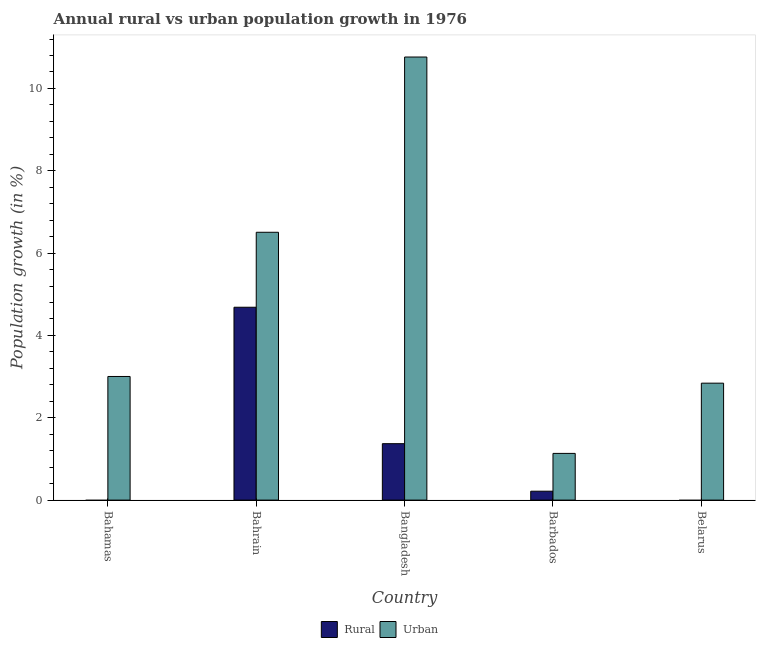How many different coloured bars are there?
Your answer should be compact. 2. How many bars are there on the 2nd tick from the left?
Your response must be concise. 2. How many bars are there on the 4th tick from the right?
Offer a terse response. 2. What is the label of the 1st group of bars from the left?
Offer a terse response. Bahamas. In how many cases, is the number of bars for a given country not equal to the number of legend labels?
Offer a very short reply. 2. What is the urban population growth in Bangladesh?
Provide a succinct answer. 10.76. Across all countries, what is the maximum urban population growth?
Your answer should be very brief. 10.76. Across all countries, what is the minimum urban population growth?
Your answer should be very brief. 1.13. In which country was the rural population growth maximum?
Make the answer very short. Bahrain. What is the total rural population growth in the graph?
Provide a succinct answer. 6.27. What is the difference between the urban population growth in Bahamas and that in Barbados?
Offer a very short reply. 1.87. What is the difference between the urban population growth in Bahrain and the rural population growth in Belarus?
Provide a succinct answer. 6.51. What is the average urban population growth per country?
Your response must be concise. 4.85. What is the difference between the rural population growth and urban population growth in Barbados?
Offer a very short reply. -0.92. In how many countries, is the urban population growth greater than 4 %?
Your answer should be very brief. 2. What is the ratio of the urban population growth in Bahrain to that in Barbados?
Offer a very short reply. 5.74. Is the urban population growth in Bangladesh less than that in Belarus?
Your answer should be very brief. No. What is the difference between the highest and the second highest urban population growth?
Give a very brief answer. 4.26. What is the difference between the highest and the lowest rural population growth?
Provide a short and direct response. 4.69. Is the sum of the rural population growth in Bahrain and Barbados greater than the maximum urban population growth across all countries?
Your response must be concise. No. Are all the bars in the graph horizontal?
Give a very brief answer. No. How many countries are there in the graph?
Provide a short and direct response. 5. Are the values on the major ticks of Y-axis written in scientific E-notation?
Offer a very short reply. No. Where does the legend appear in the graph?
Provide a short and direct response. Bottom center. How many legend labels are there?
Keep it short and to the point. 2. How are the legend labels stacked?
Make the answer very short. Horizontal. What is the title of the graph?
Your answer should be very brief. Annual rural vs urban population growth in 1976. What is the label or title of the X-axis?
Your response must be concise. Country. What is the label or title of the Y-axis?
Offer a very short reply. Population growth (in %). What is the Population growth (in %) in Urban  in Bahamas?
Provide a succinct answer. 3. What is the Population growth (in %) of Rural in Bahrain?
Your response must be concise. 4.69. What is the Population growth (in %) in Urban  in Bahrain?
Your answer should be compact. 6.51. What is the Population growth (in %) of Rural in Bangladesh?
Your response must be concise. 1.37. What is the Population growth (in %) in Urban  in Bangladesh?
Make the answer very short. 10.76. What is the Population growth (in %) of Rural in Barbados?
Provide a succinct answer. 0.22. What is the Population growth (in %) of Urban  in Barbados?
Make the answer very short. 1.13. What is the Population growth (in %) of Urban  in Belarus?
Your answer should be compact. 2.84. Across all countries, what is the maximum Population growth (in %) in Rural?
Your response must be concise. 4.69. Across all countries, what is the maximum Population growth (in %) in Urban ?
Provide a short and direct response. 10.76. Across all countries, what is the minimum Population growth (in %) of Urban ?
Your answer should be very brief. 1.13. What is the total Population growth (in %) of Rural in the graph?
Make the answer very short. 6.27. What is the total Population growth (in %) in Urban  in the graph?
Your answer should be compact. 24.25. What is the difference between the Population growth (in %) in Urban  in Bahamas and that in Bahrain?
Your answer should be compact. -3.5. What is the difference between the Population growth (in %) in Urban  in Bahamas and that in Bangladesh?
Your answer should be compact. -7.76. What is the difference between the Population growth (in %) of Urban  in Bahamas and that in Barbados?
Your answer should be very brief. 1.87. What is the difference between the Population growth (in %) in Urban  in Bahamas and that in Belarus?
Keep it short and to the point. 0.16. What is the difference between the Population growth (in %) in Rural in Bahrain and that in Bangladesh?
Offer a very short reply. 3.31. What is the difference between the Population growth (in %) of Urban  in Bahrain and that in Bangladesh?
Make the answer very short. -4.26. What is the difference between the Population growth (in %) in Rural in Bahrain and that in Barbados?
Offer a terse response. 4.47. What is the difference between the Population growth (in %) in Urban  in Bahrain and that in Barbados?
Provide a succinct answer. 5.37. What is the difference between the Population growth (in %) of Urban  in Bahrain and that in Belarus?
Give a very brief answer. 3.67. What is the difference between the Population growth (in %) of Rural in Bangladesh and that in Barbados?
Provide a short and direct response. 1.15. What is the difference between the Population growth (in %) of Urban  in Bangladesh and that in Barbados?
Provide a succinct answer. 9.63. What is the difference between the Population growth (in %) of Urban  in Bangladesh and that in Belarus?
Give a very brief answer. 7.92. What is the difference between the Population growth (in %) in Urban  in Barbados and that in Belarus?
Your response must be concise. -1.71. What is the difference between the Population growth (in %) of Rural in Bahrain and the Population growth (in %) of Urban  in Bangladesh?
Give a very brief answer. -6.08. What is the difference between the Population growth (in %) of Rural in Bahrain and the Population growth (in %) of Urban  in Barbados?
Your answer should be very brief. 3.55. What is the difference between the Population growth (in %) of Rural in Bahrain and the Population growth (in %) of Urban  in Belarus?
Make the answer very short. 1.84. What is the difference between the Population growth (in %) of Rural in Bangladesh and the Population growth (in %) of Urban  in Barbados?
Ensure brevity in your answer.  0.24. What is the difference between the Population growth (in %) in Rural in Bangladesh and the Population growth (in %) in Urban  in Belarus?
Provide a short and direct response. -1.47. What is the difference between the Population growth (in %) of Rural in Barbados and the Population growth (in %) of Urban  in Belarus?
Make the answer very short. -2.62. What is the average Population growth (in %) in Rural per country?
Make the answer very short. 1.25. What is the average Population growth (in %) in Urban  per country?
Your answer should be compact. 4.85. What is the difference between the Population growth (in %) in Rural and Population growth (in %) in Urban  in Bahrain?
Your response must be concise. -1.82. What is the difference between the Population growth (in %) in Rural and Population growth (in %) in Urban  in Bangladesh?
Offer a terse response. -9.39. What is the difference between the Population growth (in %) in Rural and Population growth (in %) in Urban  in Barbados?
Your response must be concise. -0.92. What is the ratio of the Population growth (in %) of Urban  in Bahamas to that in Bahrain?
Provide a succinct answer. 0.46. What is the ratio of the Population growth (in %) of Urban  in Bahamas to that in Bangladesh?
Your answer should be very brief. 0.28. What is the ratio of the Population growth (in %) in Urban  in Bahamas to that in Barbados?
Offer a terse response. 2.65. What is the ratio of the Population growth (in %) of Urban  in Bahamas to that in Belarus?
Make the answer very short. 1.06. What is the ratio of the Population growth (in %) in Rural in Bahrain to that in Bangladesh?
Make the answer very short. 3.42. What is the ratio of the Population growth (in %) of Urban  in Bahrain to that in Bangladesh?
Your response must be concise. 0.6. What is the ratio of the Population growth (in %) of Rural in Bahrain to that in Barbados?
Provide a short and direct response. 21.66. What is the ratio of the Population growth (in %) in Urban  in Bahrain to that in Barbados?
Your response must be concise. 5.74. What is the ratio of the Population growth (in %) in Urban  in Bahrain to that in Belarus?
Ensure brevity in your answer.  2.29. What is the ratio of the Population growth (in %) in Rural in Bangladesh to that in Barbados?
Give a very brief answer. 6.34. What is the ratio of the Population growth (in %) in Urban  in Bangladesh to that in Barbados?
Your answer should be compact. 9.49. What is the ratio of the Population growth (in %) in Urban  in Bangladesh to that in Belarus?
Offer a very short reply. 3.79. What is the ratio of the Population growth (in %) of Urban  in Barbados to that in Belarus?
Ensure brevity in your answer.  0.4. What is the difference between the highest and the second highest Population growth (in %) in Rural?
Offer a terse response. 3.31. What is the difference between the highest and the second highest Population growth (in %) of Urban ?
Ensure brevity in your answer.  4.26. What is the difference between the highest and the lowest Population growth (in %) of Rural?
Make the answer very short. 4.69. What is the difference between the highest and the lowest Population growth (in %) of Urban ?
Ensure brevity in your answer.  9.63. 